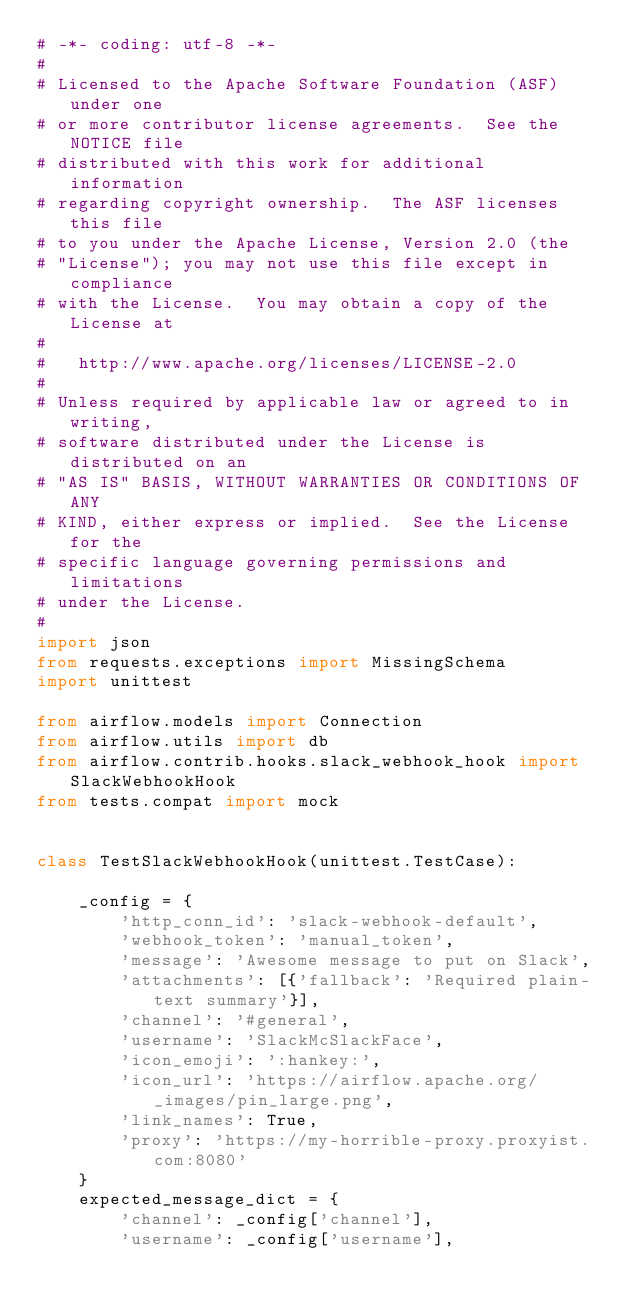Convert code to text. <code><loc_0><loc_0><loc_500><loc_500><_Python_># -*- coding: utf-8 -*-
#
# Licensed to the Apache Software Foundation (ASF) under one
# or more contributor license agreements.  See the NOTICE file
# distributed with this work for additional information
# regarding copyright ownership.  The ASF licenses this file
# to you under the Apache License, Version 2.0 (the
# "License"); you may not use this file except in compliance
# with the License.  You may obtain a copy of the License at
#
#   http://www.apache.org/licenses/LICENSE-2.0
#
# Unless required by applicable law or agreed to in writing,
# software distributed under the License is distributed on an
# "AS IS" BASIS, WITHOUT WARRANTIES OR CONDITIONS OF ANY
# KIND, either express or implied.  See the License for the
# specific language governing permissions and limitations
# under the License.
#
import json
from requests.exceptions import MissingSchema
import unittest

from airflow.models import Connection
from airflow.utils import db
from airflow.contrib.hooks.slack_webhook_hook import SlackWebhookHook
from tests.compat import mock


class TestSlackWebhookHook(unittest.TestCase):

    _config = {
        'http_conn_id': 'slack-webhook-default',
        'webhook_token': 'manual_token',
        'message': 'Awesome message to put on Slack',
        'attachments': [{'fallback': 'Required plain-text summary'}],
        'channel': '#general',
        'username': 'SlackMcSlackFace',
        'icon_emoji': ':hankey:',
        'icon_url': 'https://airflow.apache.org/_images/pin_large.png',
        'link_names': True,
        'proxy': 'https://my-horrible-proxy.proxyist.com:8080'
    }
    expected_message_dict = {
        'channel': _config['channel'],
        'username': _config['username'],</code> 